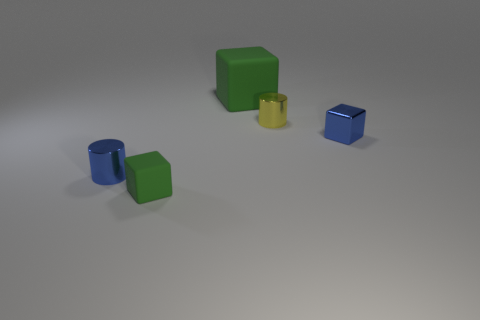Subtract all matte cubes. How many cubes are left? 1 Add 3 small purple rubber blocks. How many objects exist? 8 Subtract all blocks. How many objects are left? 2 Subtract all large green blocks. Subtract all small gray rubber spheres. How many objects are left? 4 Add 1 tiny blue objects. How many tiny blue objects are left? 3 Add 4 large green rubber cylinders. How many large green rubber cylinders exist? 4 Subtract 0 brown balls. How many objects are left? 5 